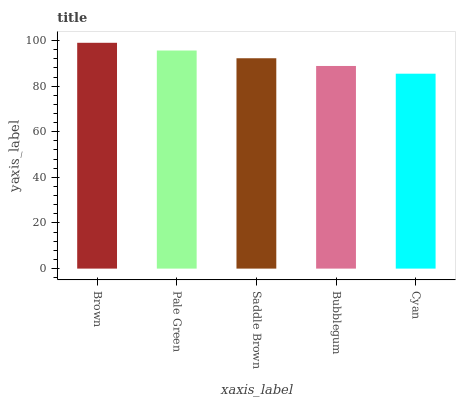Is Cyan the minimum?
Answer yes or no. Yes. Is Brown the maximum?
Answer yes or no. Yes. Is Pale Green the minimum?
Answer yes or no. No. Is Pale Green the maximum?
Answer yes or no. No. Is Brown greater than Pale Green?
Answer yes or no. Yes. Is Pale Green less than Brown?
Answer yes or no. Yes. Is Pale Green greater than Brown?
Answer yes or no. No. Is Brown less than Pale Green?
Answer yes or no. No. Is Saddle Brown the high median?
Answer yes or no. Yes. Is Saddle Brown the low median?
Answer yes or no. Yes. Is Bubblegum the high median?
Answer yes or no. No. Is Brown the low median?
Answer yes or no. No. 